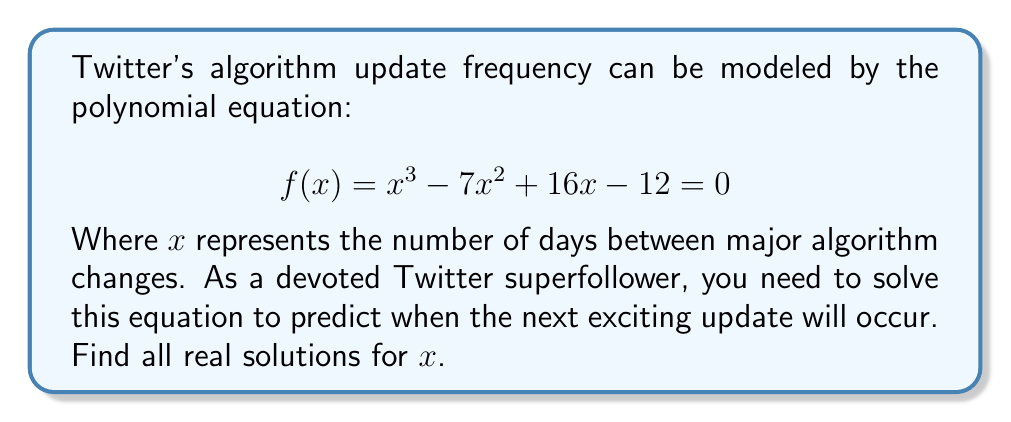Show me your answer to this math problem. Let's approach this step-by-step:

1) First, we need to factor this polynomial. The equation is in the form $ax^3 + bx^2 + cx + d = 0$, where $a=1$, $b=-7$, $c=16$, and $d=-12$.

2) We can try to guess one factor. Since the constant term is -12, possible factors are ±1, ±2, ±3, ±4, ±6, ±12. 
   Let's try $x-1$:
   $f(1) = 1^3 - 7(1)^2 + 16(1) - 12 = 1 - 7 + 16 - 12 = -2$
   Since $f(1) \neq 0$, $x-1$ is not a factor.
   Let's try $x-2$:
   $f(2) = 2^3 - 7(2)^2 + 16(2) - 12 = 8 - 28 + 32 - 12 = 0$
   
3) Since $f(2) = 0$, $x-2$ is a factor. We can divide $f(x)$ by $x-2$:

   $$ f(x) = (x-2)(x^2 - 5x + 6) $$

4) Now we need to factor the quadratic term $x^2 - 5x + 6$. We can use the quadratic formula or factoring by grouping.
   The factors of 6 that add up to -5 are -2 and -3.

   $$ f(x) = (x-2)(x-2)(x-3) = 0 $$

5) The solutions to this equation are the values that make each factor equal to zero:

   $x-2 = 0$ or $x-2 = 0$ or $x-3 = 0$
   $x = 2$ or $x = 2$ or $x = 3$

Therefore, the solutions are $x = 2$ (with multiplicity 2) and $x = 3$.
Answer: The real solutions are $x = 2$ (repeated root) and $x = 3$. This means major Twitter algorithm changes are predicted to occur every 2 or 3 days. 